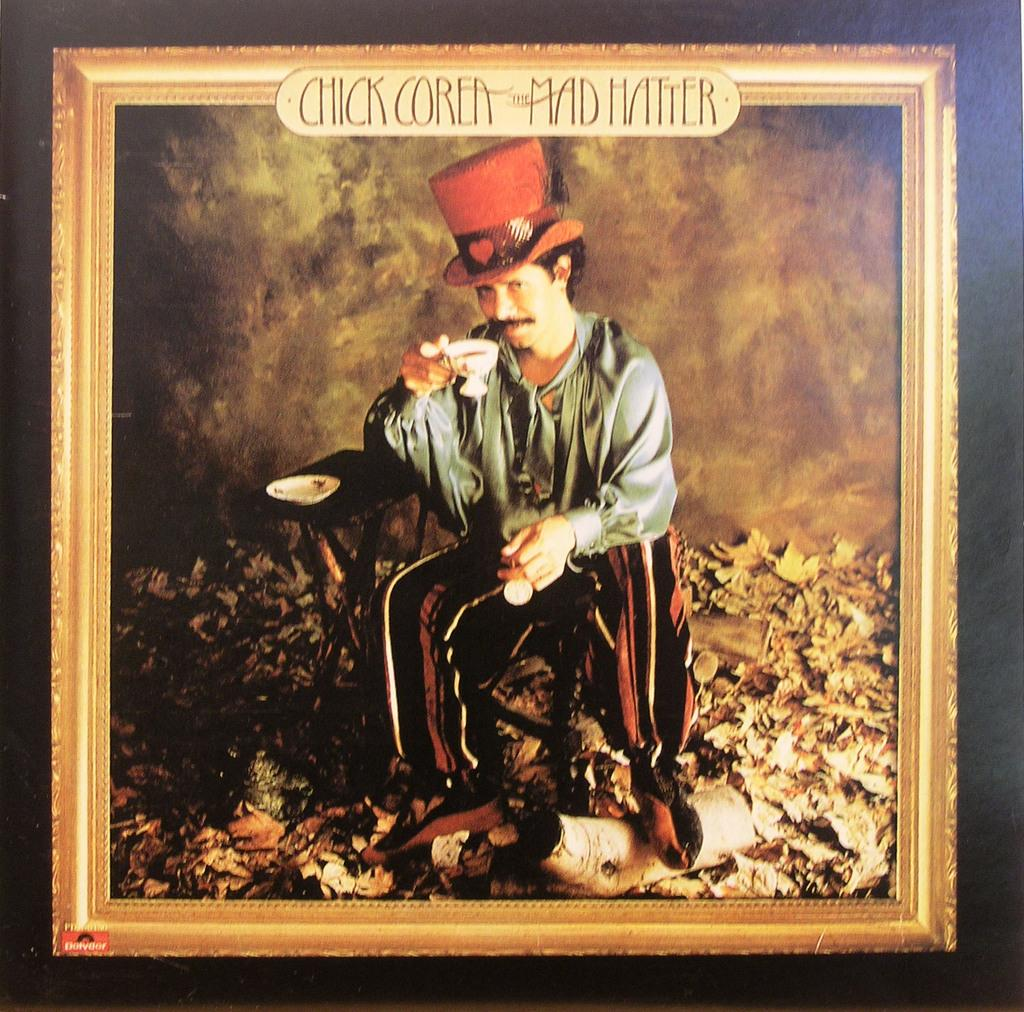<image>
Relay a brief, clear account of the picture shown. a photo of a person called the mad hatter 